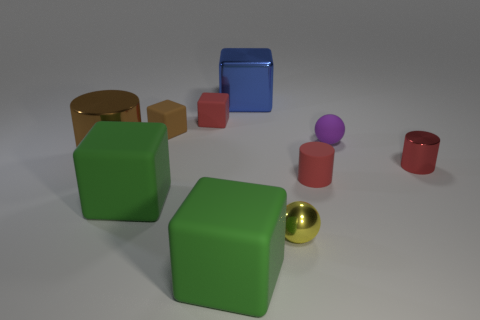Subtract all big shiny cylinders. How many cylinders are left? 2 Subtract all balls. How many objects are left? 8 Subtract 5 blocks. How many blocks are left? 0 Subtract all red blocks. How many blocks are left? 4 Subtract all red spheres. Subtract all blue cylinders. How many spheres are left? 2 Subtract all blue spheres. How many gray cylinders are left? 0 Subtract all big green things. Subtract all red objects. How many objects are left? 5 Add 5 big green cubes. How many big green cubes are left? 7 Add 2 metal spheres. How many metal spheres exist? 3 Subtract 1 brown cylinders. How many objects are left? 9 